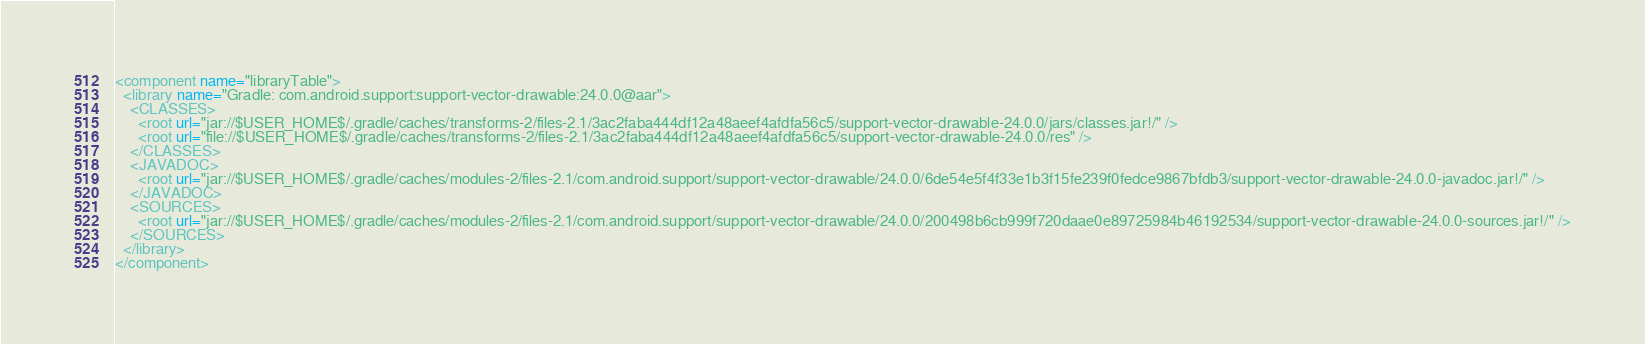Convert code to text. <code><loc_0><loc_0><loc_500><loc_500><_XML_><component name="libraryTable">
  <library name="Gradle: com.android.support:support-vector-drawable:24.0.0@aar">
    <CLASSES>
      <root url="jar://$USER_HOME$/.gradle/caches/transforms-2/files-2.1/3ac2faba444df12a48aeef4afdfa56c5/support-vector-drawable-24.0.0/jars/classes.jar!/" />
      <root url="file://$USER_HOME$/.gradle/caches/transforms-2/files-2.1/3ac2faba444df12a48aeef4afdfa56c5/support-vector-drawable-24.0.0/res" />
    </CLASSES>
    <JAVADOC>
      <root url="jar://$USER_HOME$/.gradle/caches/modules-2/files-2.1/com.android.support/support-vector-drawable/24.0.0/6de54e5f4f33e1b3f15fe239f0fedce9867bfdb3/support-vector-drawable-24.0.0-javadoc.jar!/" />
    </JAVADOC>
    <SOURCES>
      <root url="jar://$USER_HOME$/.gradle/caches/modules-2/files-2.1/com.android.support/support-vector-drawable/24.0.0/200498b6cb999f720daae0e89725984b46192534/support-vector-drawable-24.0.0-sources.jar!/" />
    </SOURCES>
  </library>
</component></code> 